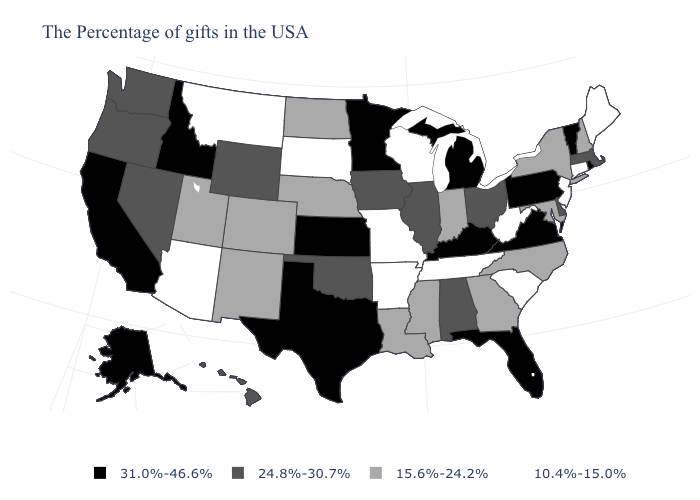Name the states that have a value in the range 10.4%-15.0%?
Short answer required. Maine, Connecticut, New Jersey, South Carolina, West Virginia, Tennessee, Wisconsin, Missouri, Arkansas, South Dakota, Montana, Arizona. Name the states that have a value in the range 31.0%-46.6%?
Keep it brief. Rhode Island, Vermont, Pennsylvania, Virginia, Florida, Michigan, Kentucky, Minnesota, Kansas, Texas, Idaho, California, Alaska. What is the highest value in the West ?
Short answer required. 31.0%-46.6%. What is the lowest value in the USA?
Give a very brief answer. 10.4%-15.0%. Does Connecticut have a lower value than West Virginia?
Keep it brief. No. How many symbols are there in the legend?
Short answer required. 4. Is the legend a continuous bar?
Be succinct. No. Does Illinois have a lower value than Minnesota?
Write a very short answer. Yes. What is the lowest value in the USA?
Answer briefly. 10.4%-15.0%. Among the states that border Indiana , does Ohio have the lowest value?
Short answer required. Yes. Name the states that have a value in the range 31.0%-46.6%?
Concise answer only. Rhode Island, Vermont, Pennsylvania, Virginia, Florida, Michigan, Kentucky, Minnesota, Kansas, Texas, Idaho, California, Alaska. What is the value of Texas?
Quick response, please. 31.0%-46.6%. Name the states that have a value in the range 24.8%-30.7%?
Concise answer only. Massachusetts, Delaware, Ohio, Alabama, Illinois, Iowa, Oklahoma, Wyoming, Nevada, Washington, Oregon, Hawaii. Name the states that have a value in the range 15.6%-24.2%?
Concise answer only. New Hampshire, New York, Maryland, North Carolina, Georgia, Indiana, Mississippi, Louisiana, Nebraska, North Dakota, Colorado, New Mexico, Utah. What is the highest value in the West ?
Short answer required. 31.0%-46.6%. 